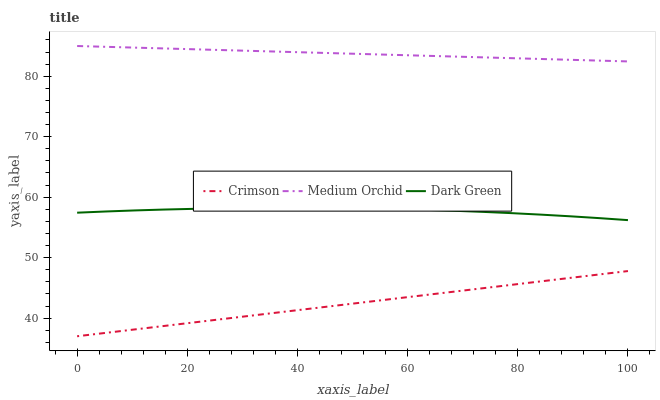Does Crimson have the minimum area under the curve?
Answer yes or no. Yes. Does Medium Orchid have the maximum area under the curve?
Answer yes or no. Yes. Does Dark Green have the minimum area under the curve?
Answer yes or no. No. Does Dark Green have the maximum area under the curve?
Answer yes or no. No. Is Crimson the smoothest?
Answer yes or no. Yes. Is Dark Green the roughest?
Answer yes or no. Yes. Is Medium Orchid the smoothest?
Answer yes or no. No. Is Medium Orchid the roughest?
Answer yes or no. No. Does Crimson have the lowest value?
Answer yes or no. Yes. Does Dark Green have the lowest value?
Answer yes or no. No. Does Medium Orchid have the highest value?
Answer yes or no. Yes. Does Dark Green have the highest value?
Answer yes or no. No. Is Crimson less than Medium Orchid?
Answer yes or no. Yes. Is Medium Orchid greater than Crimson?
Answer yes or no. Yes. Does Crimson intersect Medium Orchid?
Answer yes or no. No. 